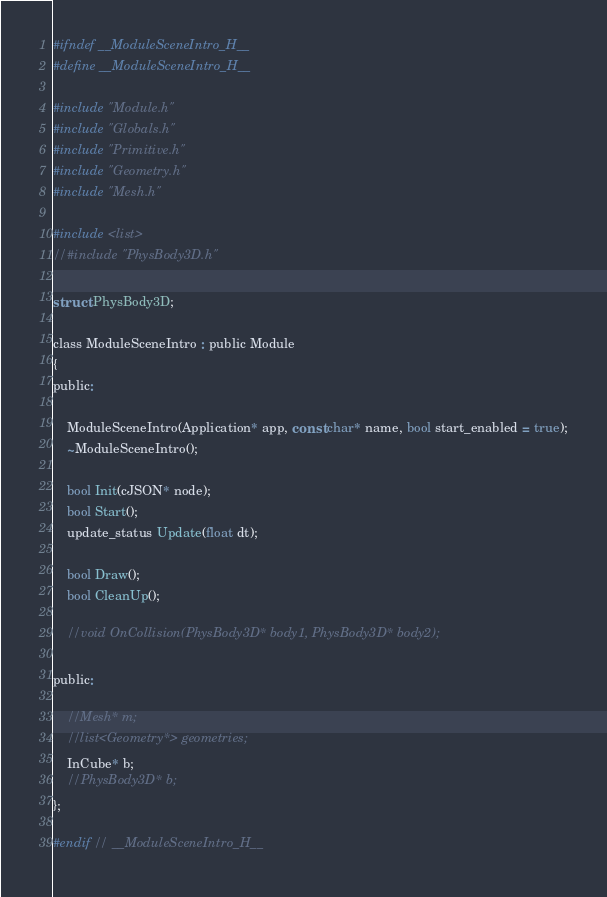Convert code to text. <code><loc_0><loc_0><loc_500><loc_500><_C_>#ifndef __ModuleSceneIntro_H__
#define __ModuleSceneIntro_H__

#include "Module.h"
#include "Globals.h"
#include "Primitive.h"
#include "Geometry.h"
#include "Mesh.h"

#include <list>
//#include "PhysBody3D.h"

struct PhysBody3D;

class ModuleSceneIntro : public Module
{
public:

	ModuleSceneIntro(Application* app, const char* name, bool start_enabled = true);
	~ModuleSceneIntro();

	bool Init(cJSON* node);
	bool Start();
	update_status Update(float dt);

	bool Draw();
	bool CleanUp();

	//void OnCollision(PhysBody3D* body1, PhysBody3D* body2);

public:
	
	//Mesh* m;
	//list<Geometry*> geometries;
	InCube* b;
	//PhysBody3D* b;
};

#endif // __ModuleSceneIntro_H__</code> 